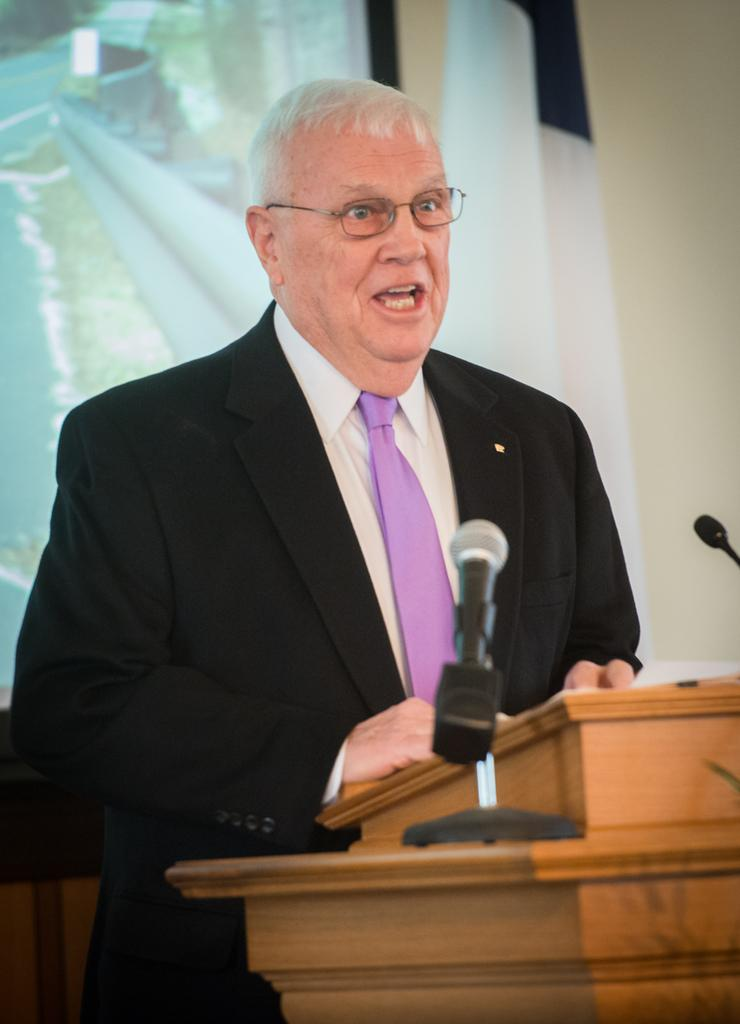What is the person in the image wearing on their face? The person in the image is wearing specs. What object can be seen in front of the person? There is a podium in the image. What devices are present for amplifying sound? There are microphones in the image. What can be seen behind the person? There is a wall in the background of the image. What is used for displaying information or visuals? There is a screen in the image. Can you see a giraffe walking in the image? No, there is no giraffe or any indication of a walking animal in the image. What time of day is it in the image, considering the presence of a night scene? The image does not depict a night scene; the presence of a wall, screen, and microphones suggests an indoor setting with artificial lighting. 